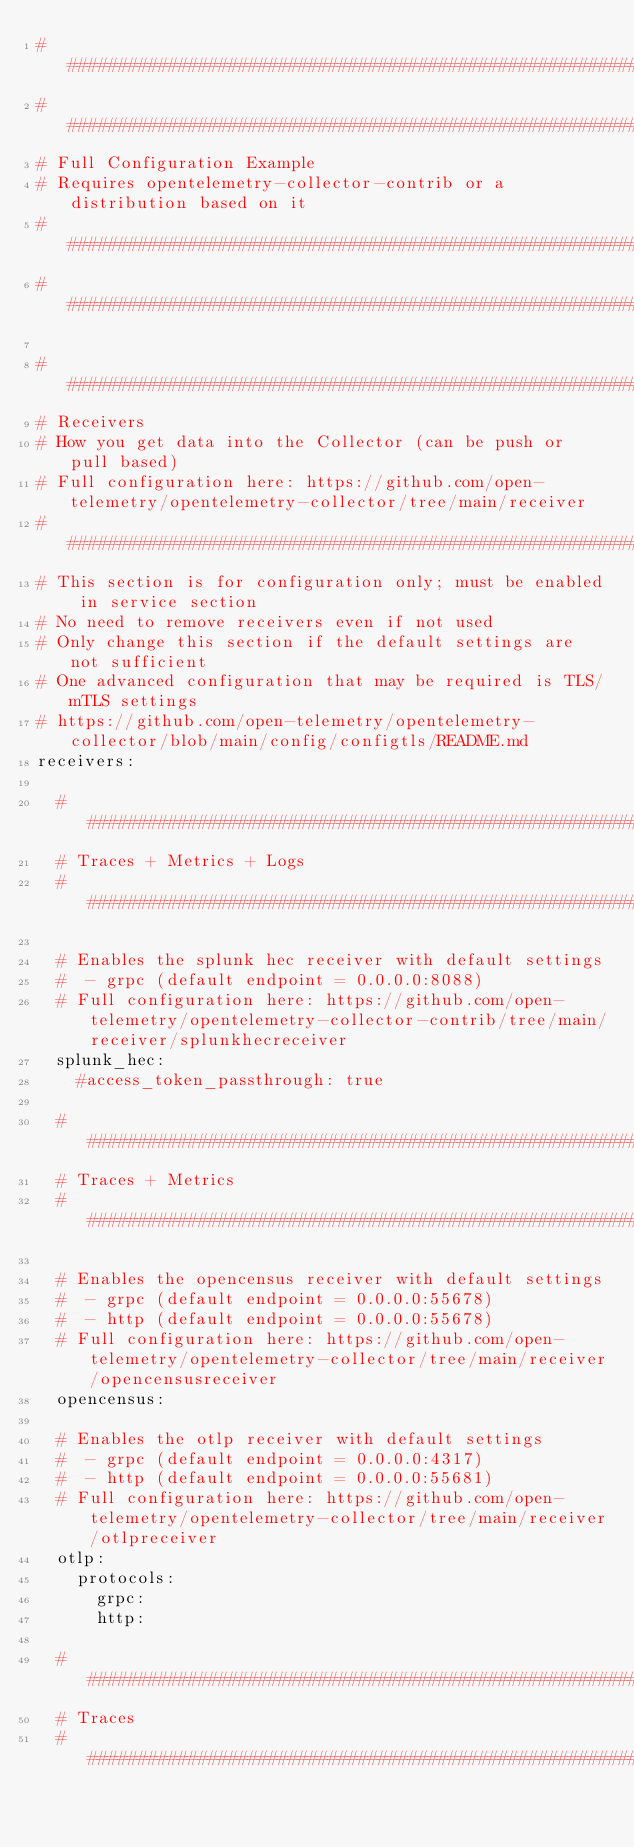<code> <loc_0><loc_0><loc_500><loc_500><_YAML_>###############################################################################
###############################################################################
# Full Configuration Example
# Requires opentelemetry-collector-contrib or a distribution based on it
###############################################################################
###############################################################################

###############################################################################
# Receivers
# How you get data into the Collector (can be push or pull based)
# Full configuration here: https://github.com/open-telemetry/opentelemetry-collector/tree/main/receiver
###############################################################################
# This section is for configuration only; must be enabled in service section
# No need to remove receivers even if not used
# Only change this section if the default settings are not sufficient
# One advanced configuration that may be required is TLS/mTLS settings
# https://github.com/open-telemetry/opentelemetry-collector/blob/main/config/configtls/README.md
receivers:

  #############################################################################
  # Traces + Metrics + Logs
  #############################################################################

  # Enables the splunk hec receiver with default settings
  #  - grpc (default endpoint = 0.0.0.0:8088)
  # Full configuration here: https://github.com/open-telemetry/opentelemetry-collector-contrib/tree/main/receiver/splunkhecreceiver
  splunk_hec:
    #access_token_passthrough: true

  #############################################################################
  # Traces + Metrics
  #############################################################################

  # Enables the opencensus receiver with default settings
  #  - grpc (default endpoint = 0.0.0.0:55678)
  #  - http (default endpoint = 0.0.0.0:55678)
  # Full configuration here: https://github.com/open-telemetry/opentelemetry-collector/tree/main/receiver/opencensusreceiver
  opencensus:

  # Enables the otlp receiver with default settings
  #  - grpc (default endpoint = 0.0.0.0:4317)
  #  - http (default endpoint = 0.0.0.0:55681)
  # Full configuration here: https://github.com/open-telemetry/opentelemetry-collector/tree/main/receiver/otlpreceiver
  otlp:
    protocols:
      grpc:
      http:

  #############################################################################
  # Traces
  #############################################################################
</code> 